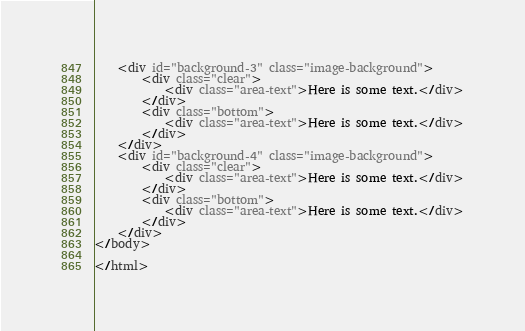Convert code to text. <code><loc_0><loc_0><loc_500><loc_500><_HTML_>    <div id="background-3" class="image-background">
        <div class="clear">
            <div class="area-text">Here is some text.</div>
        </div>
        <div class="bottom">
            <div class="area-text">Here is some text.</div>
        </div>
    </div>
    <div id="background-4" class="image-background">
        <div class="clear">
            <div class="area-text">Here is some text.</div>
        </div>
        <div class="bottom">
            <div class="area-text">Here is some text.</div>
        </div>
    </div>
</body>

</html>
</code> 